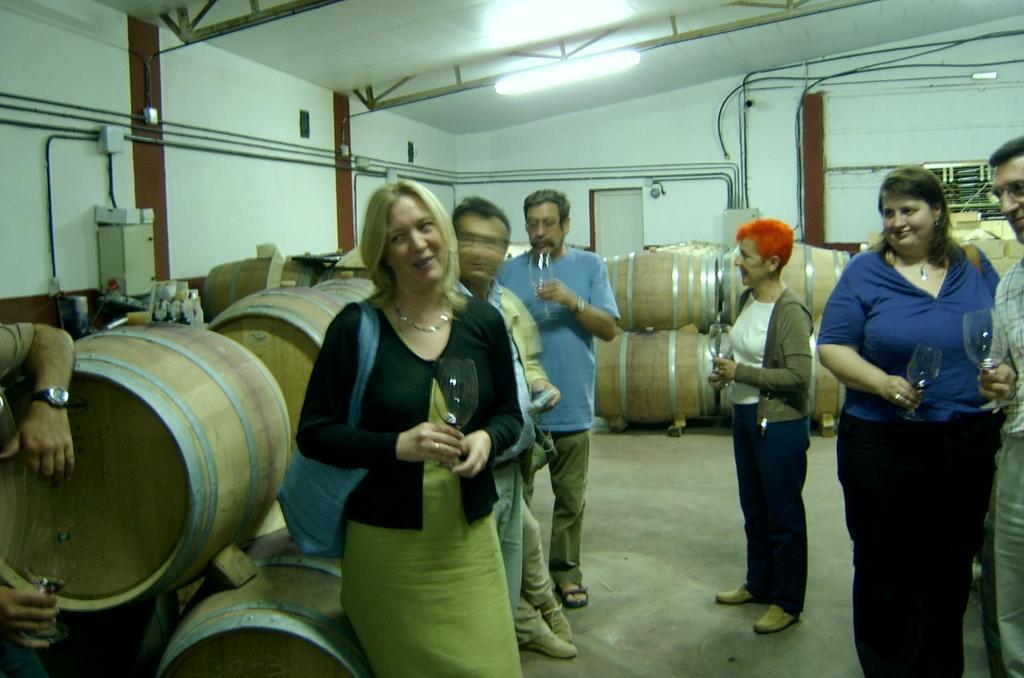In one or two sentences, can you explain what this image depicts? There are many people holding glasses. Lady in the front is wearing a bag. In the back there are many wooden barrels. In the back there's a wall. On the wall there are pipes. On the ceiling there is a light. 